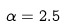<formula> <loc_0><loc_0><loc_500><loc_500>\alpha = 2 . 5</formula> 